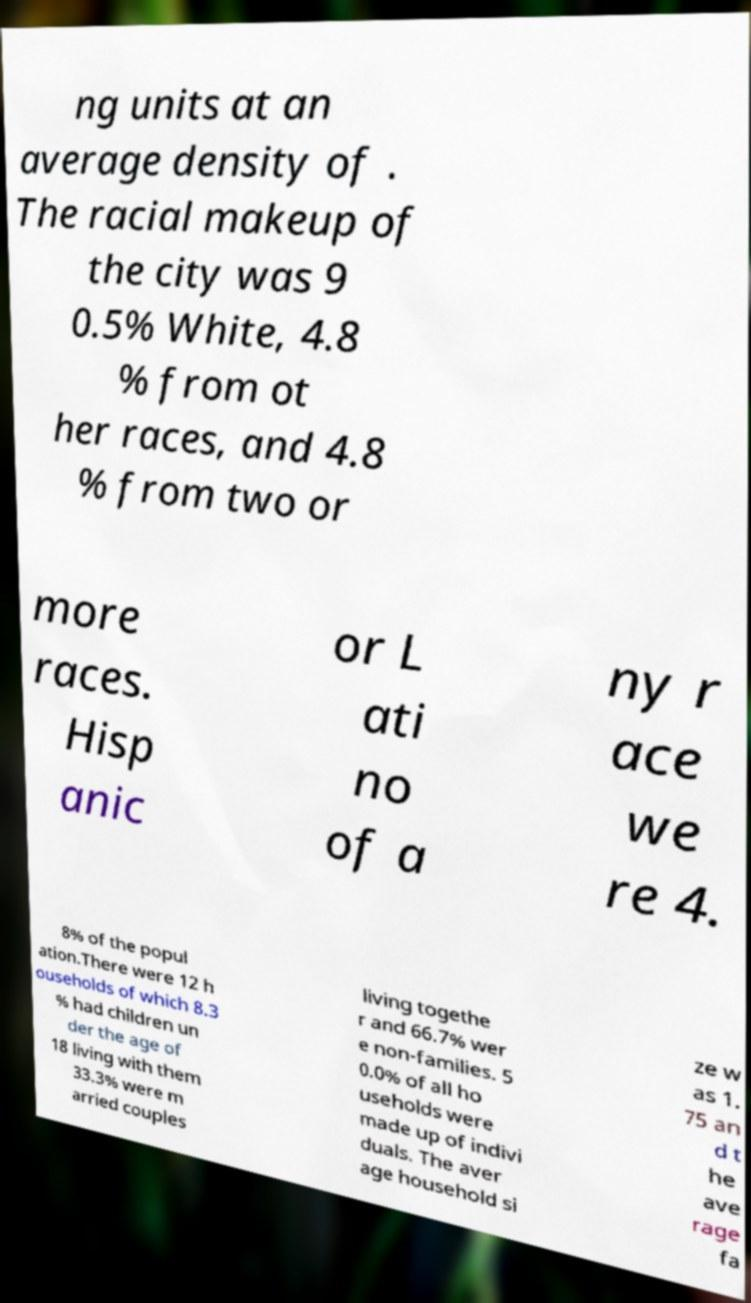Could you assist in decoding the text presented in this image and type it out clearly? ng units at an average density of . The racial makeup of the city was 9 0.5% White, 4.8 % from ot her races, and 4.8 % from two or more races. Hisp anic or L ati no of a ny r ace we re 4. 8% of the popul ation.There were 12 h ouseholds of which 8.3 % had children un der the age of 18 living with them 33.3% were m arried couples living togethe r and 66.7% wer e non-families. 5 0.0% of all ho useholds were made up of indivi duals. The aver age household si ze w as 1. 75 an d t he ave rage fa 